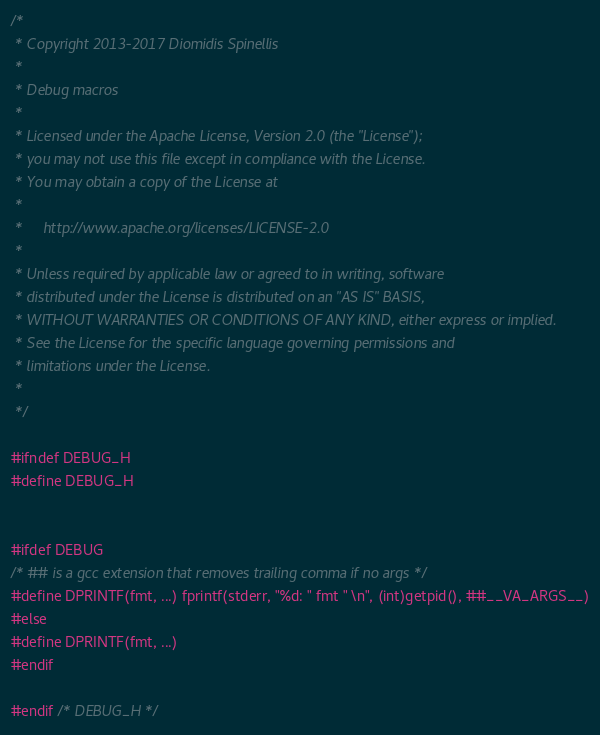<code> <loc_0><loc_0><loc_500><loc_500><_C_>/*
 * Copyright 2013-2017 Diomidis Spinellis
 *
 * Debug macros
 *
 * Licensed under the Apache License, Version 2.0 (the "License");
 * you may not use this file except in compliance with the License.
 * You may obtain a copy of the License at
 *
 *     http://www.apache.org/licenses/LICENSE-2.0
 *
 * Unless required by applicable law or agreed to in writing, software
 * distributed under the License is distributed on an "AS IS" BASIS,
 * WITHOUT WARRANTIES OR CONDITIONS OF ANY KIND, either express or implied.
 * See the License for the specific language governing permissions and
 * limitations under the License.
 *
 */

#ifndef DEBUG_H
#define DEBUG_H


#ifdef DEBUG
/* ## is a gcc extension that removes trailing comma if no args */
#define DPRINTF(fmt, ...) fprintf(stderr, "%d: " fmt " \n", (int)getpid(), ##__VA_ARGS__)
#else
#define DPRINTF(fmt, ...)
#endif

#endif /* DEBUG_H */
</code> 